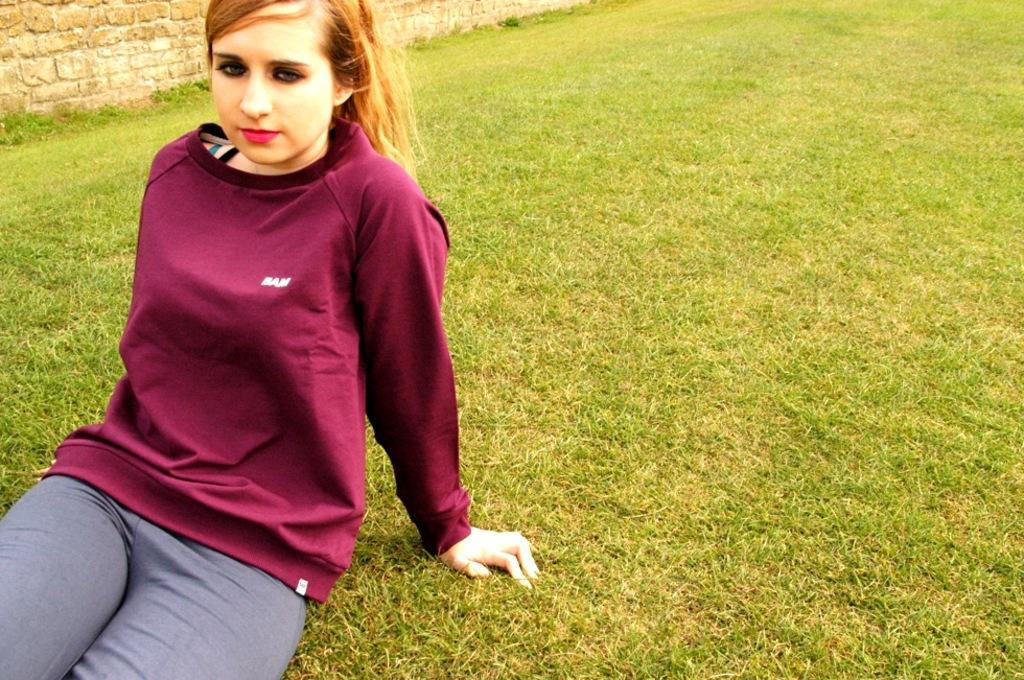Who is the main subject in the image? There is a girl in the image. What is the girl doing in the image? The girl is sitting on the grassy land. What is the girl wearing in the image? The girl is wearing a maroon color t-shirt and jeans. What can be seen in the top left of the image? There is a wall visible in the top left of the image. What arithmetic problem is the girl solving in the image? There is no arithmetic problem visible in the image. How does the girl protect herself from the rainstorm in the image? There is no rainstorm present in the image, so the girl does not need to protect herself from it. 